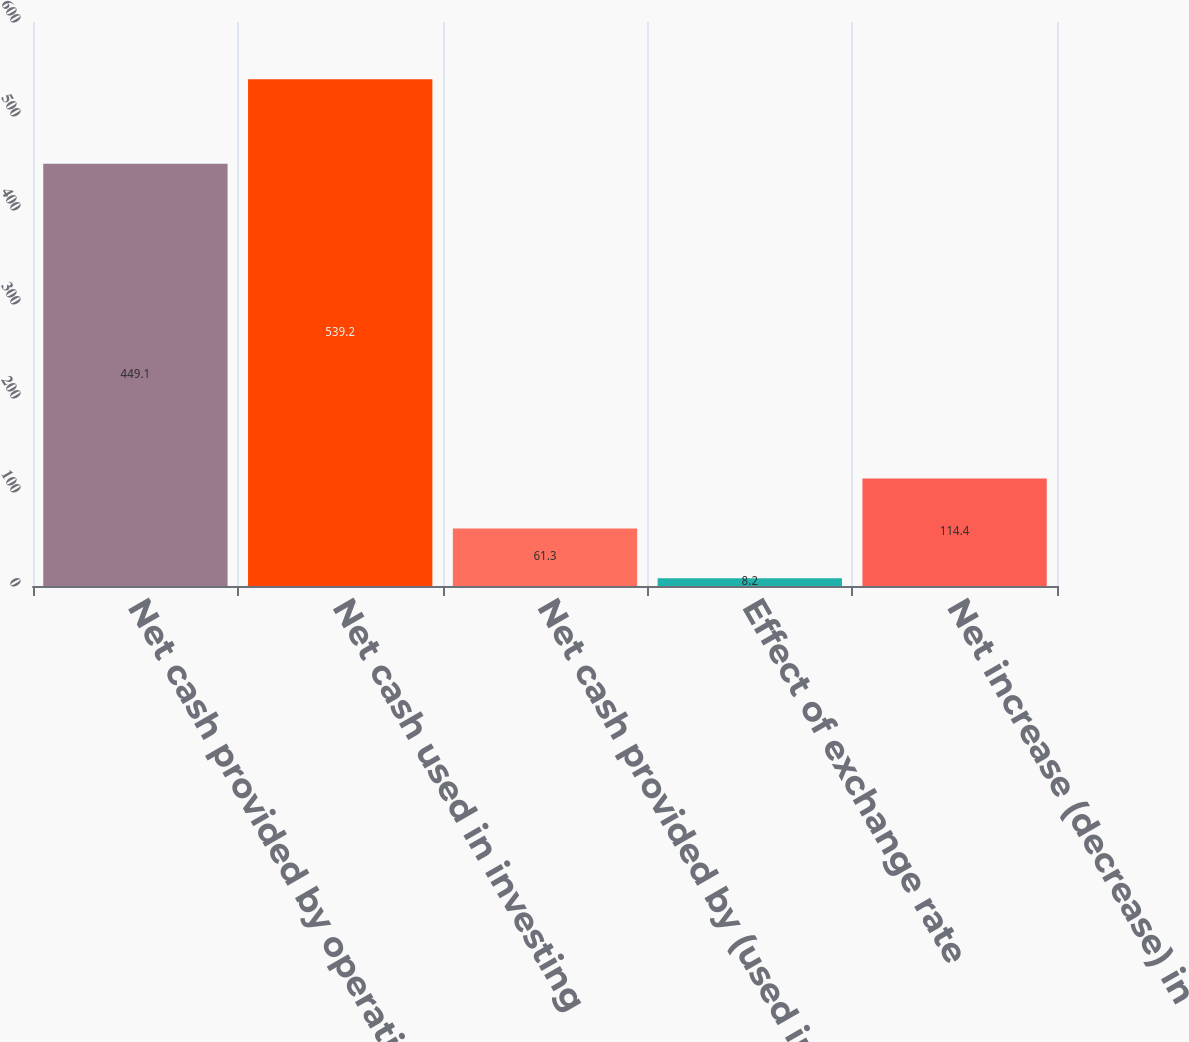Convert chart. <chart><loc_0><loc_0><loc_500><loc_500><bar_chart><fcel>Net cash provided by operating<fcel>Net cash used in investing<fcel>Net cash provided by (used in)<fcel>Effect of exchange rate<fcel>Net increase (decrease) in<nl><fcel>449.1<fcel>539.2<fcel>61.3<fcel>8.2<fcel>114.4<nl></chart> 